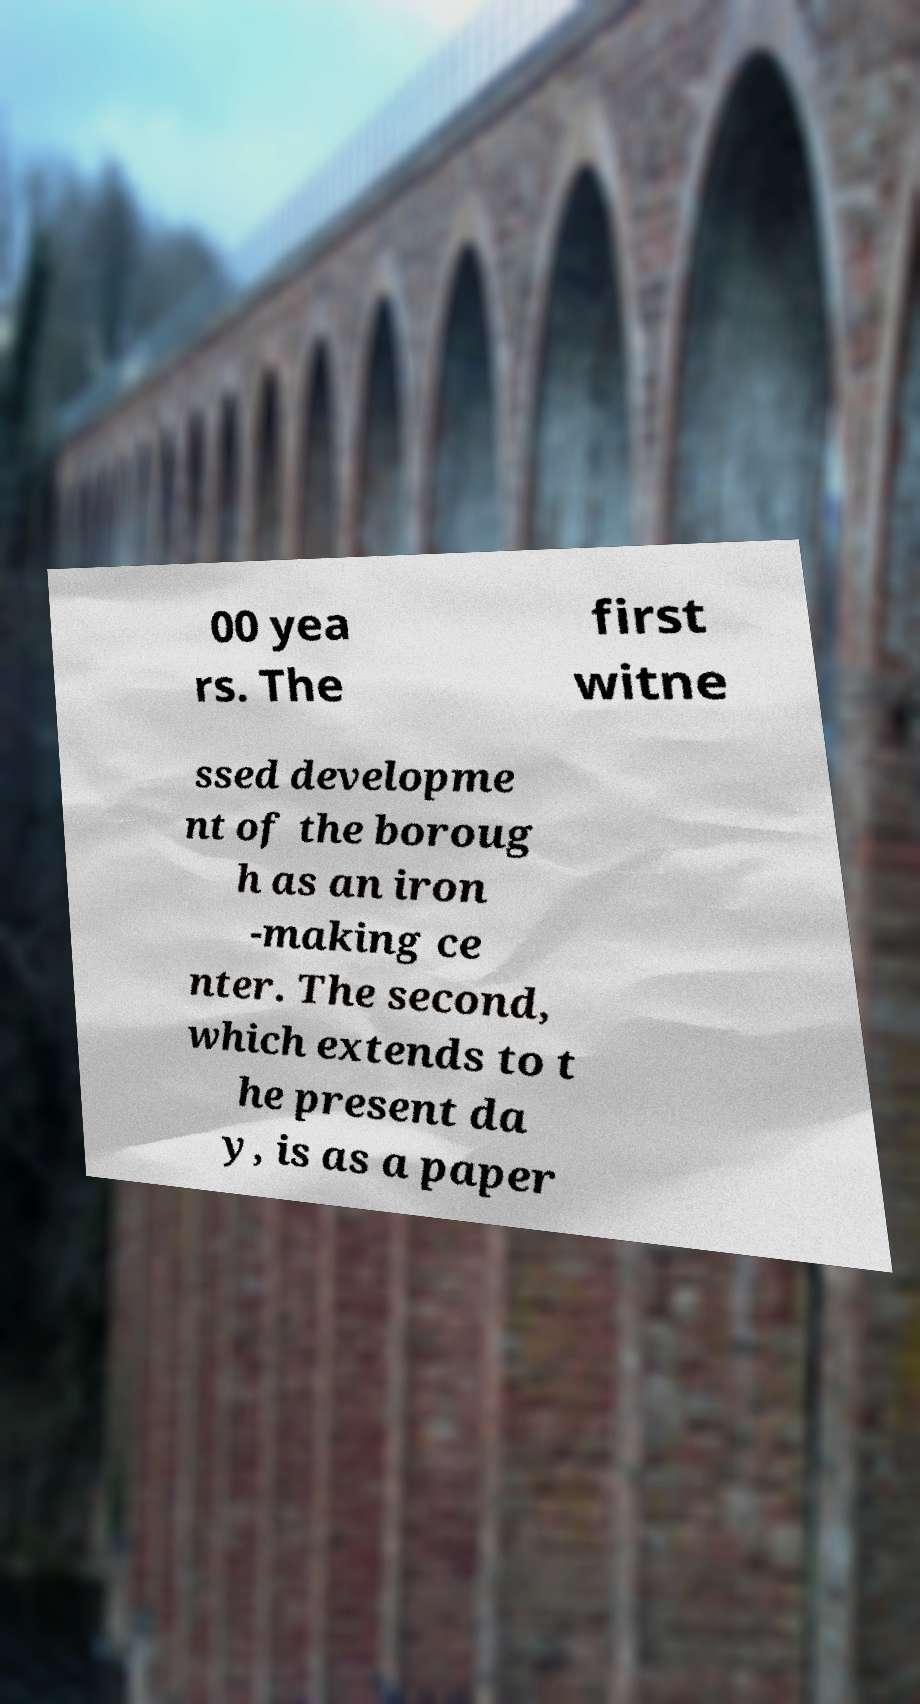Please identify and transcribe the text found in this image. 00 yea rs. The first witne ssed developme nt of the boroug h as an iron -making ce nter. The second, which extends to t he present da y, is as a paper 